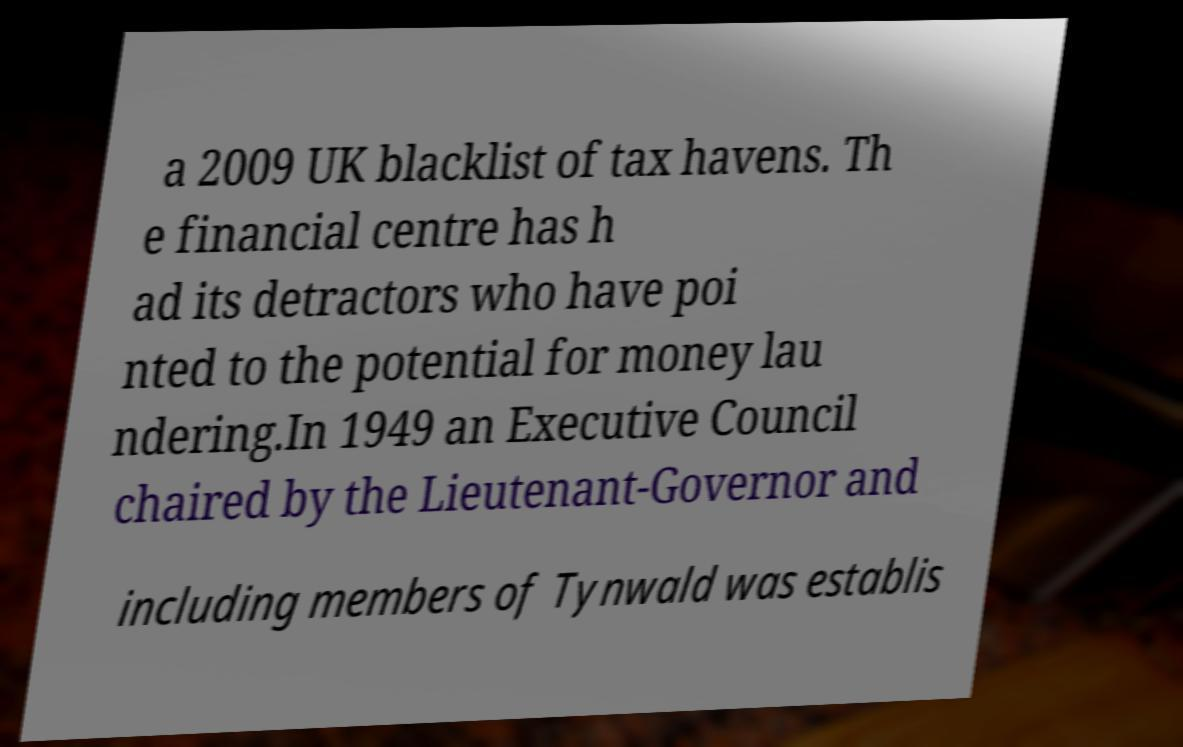I need the written content from this picture converted into text. Can you do that? a 2009 UK blacklist of tax havens. Th e financial centre has h ad its detractors who have poi nted to the potential for money lau ndering.In 1949 an Executive Council chaired by the Lieutenant-Governor and including members of Tynwald was establis 